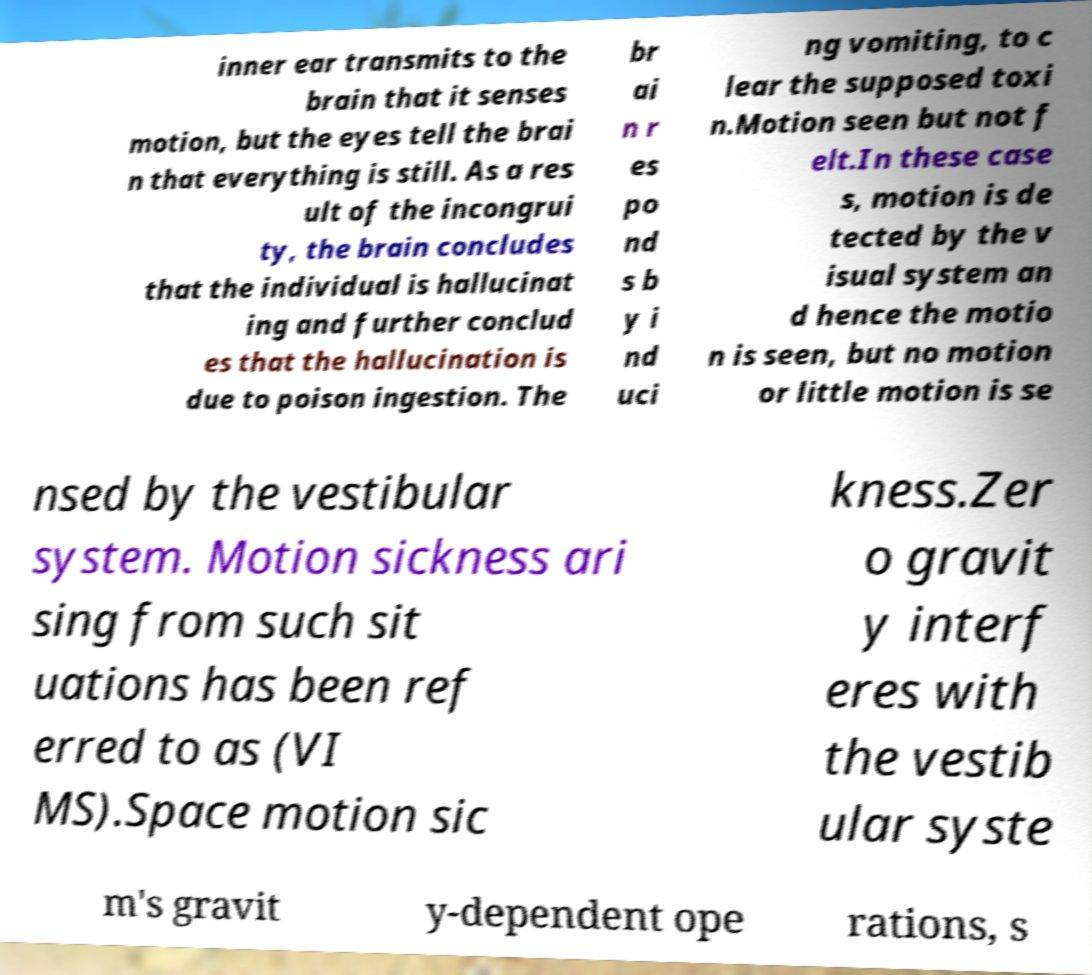Could you assist in decoding the text presented in this image and type it out clearly? inner ear transmits to the brain that it senses motion, but the eyes tell the brai n that everything is still. As a res ult of the incongrui ty, the brain concludes that the individual is hallucinat ing and further conclud es that the hallucination is due to poison ingestion. The br ai n r es po nd s b y i nd uci ng vomiting, to c lear the supposed toxi n.Motion seen but not f elt.In these case s, motion is de tected by the v isual system an d hence the motio n is seen, but no motion or little motion is se nsed by the vestibular system. Motion sickness ari sing from such sit uations has been ref erred to as (VI MS).Space motion sic kness.Zer o gravit y interf eres with the vestib ular syste m's gravit y-dependent ope rations, s 